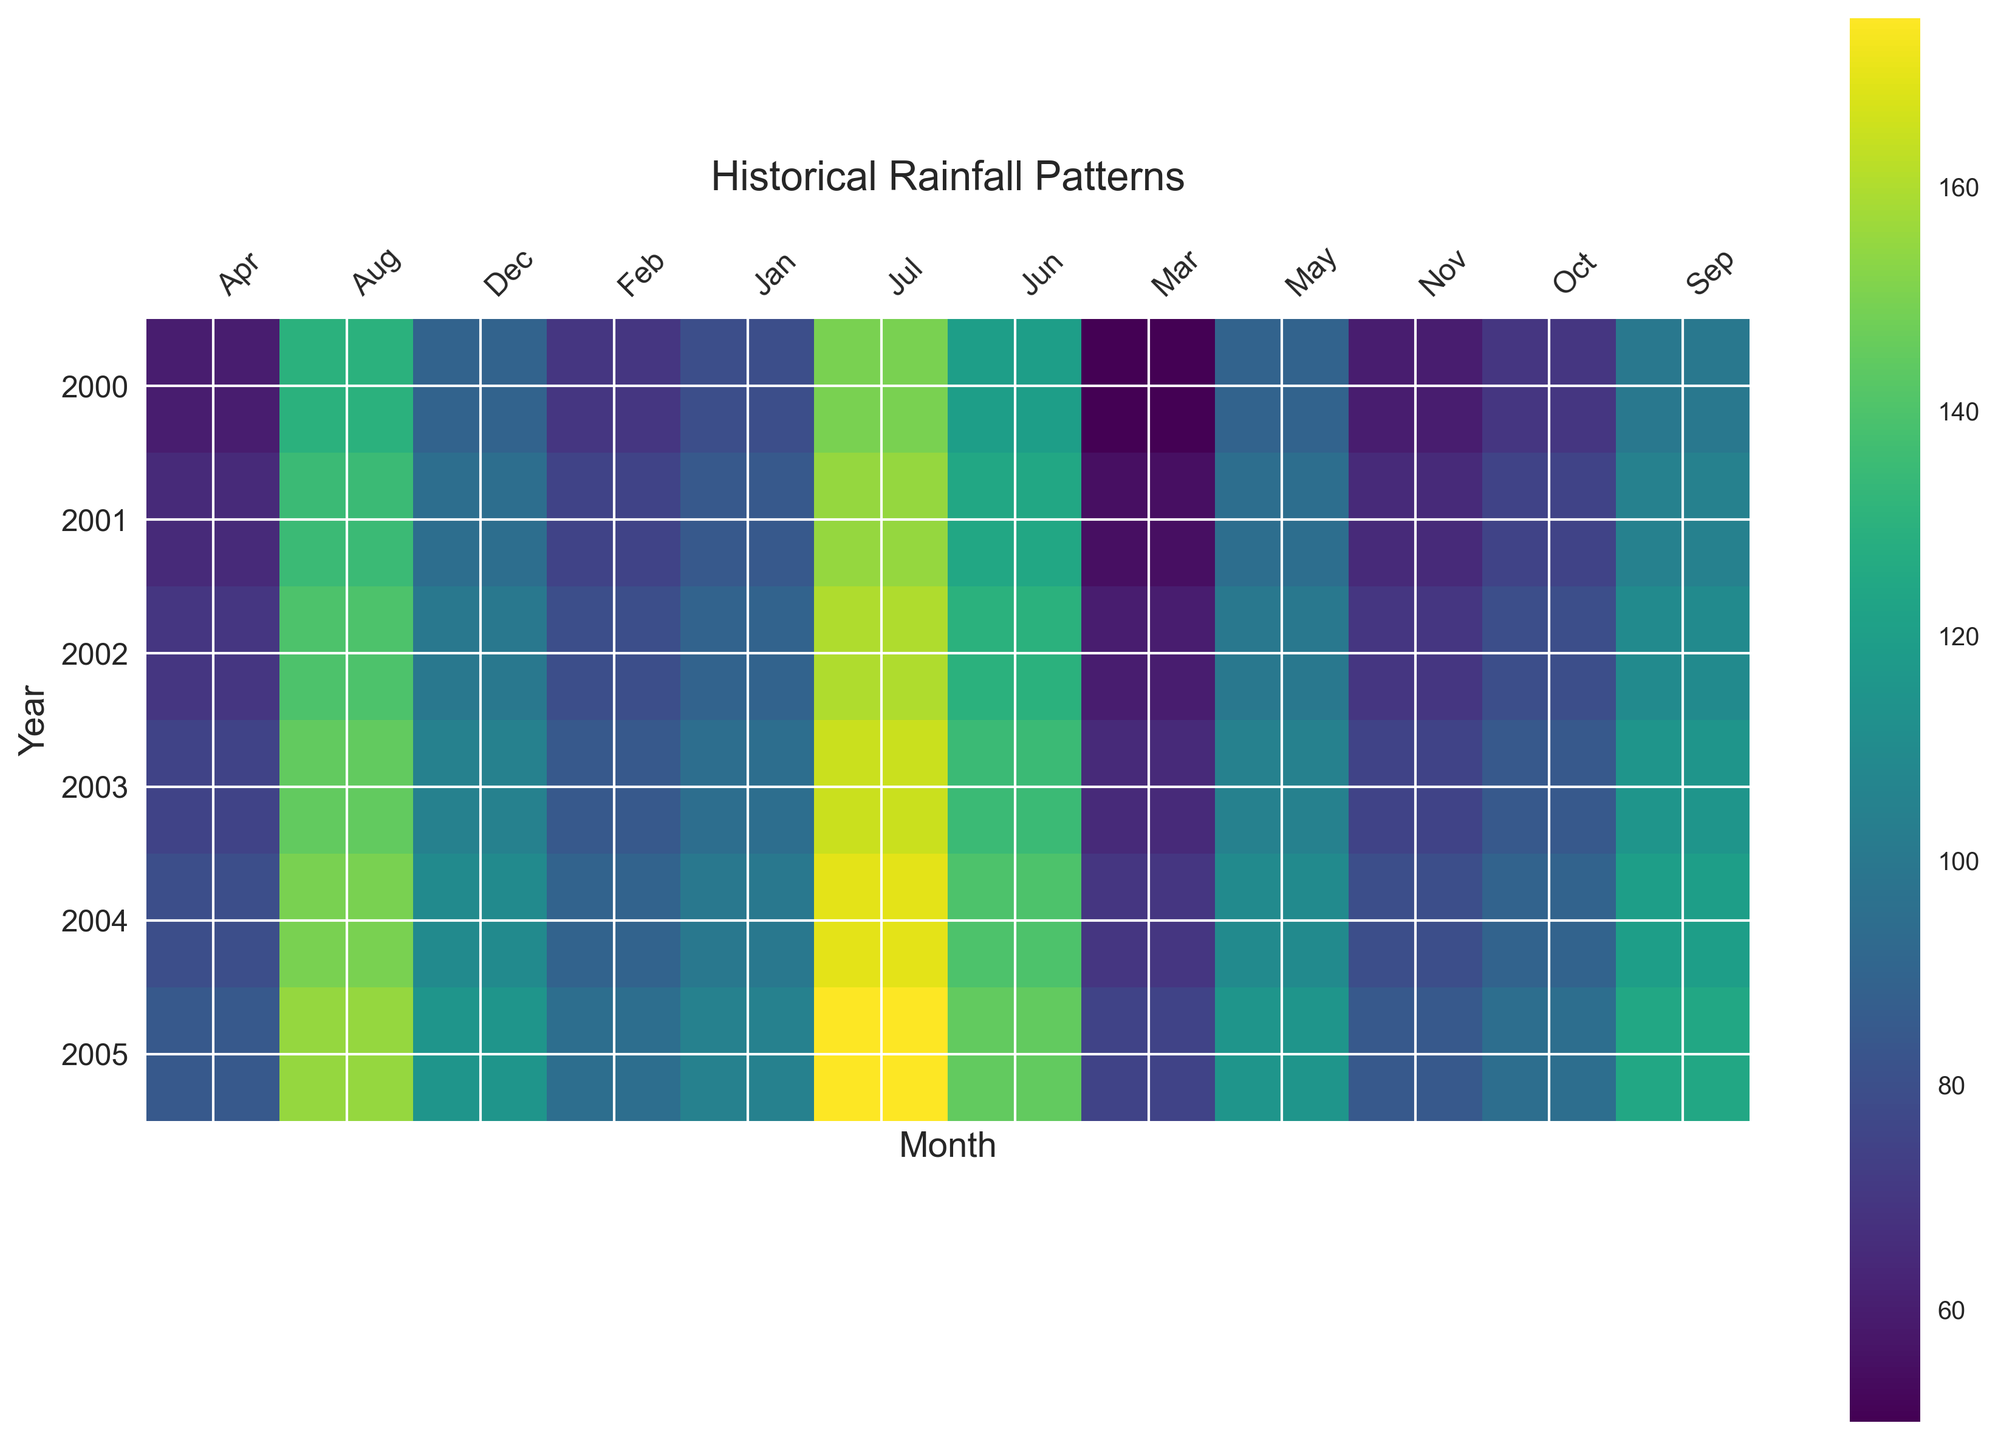What year experienced the highest average rainfall in July? Look for the month of July across all years, and identify the darkest hue which represents the highest rainfall. Reference the corresponding year.
Answer: 2005 Which year had the lowest average rainfall in March? Examine the March data across all years and seek the lightest hue indicating the lowest rainfall. The corresponding year is your answer.
Answer: 2000 Compare the average rainfall in August and September for the year 2004. Which month had more rainfall and by how much? Locate August and September for 2004 on the x-axis, compare the colors, and refer to the scale. The darker hue represents higher rainfall. Check the difference in shades.
Answer: August by 30 mm What is the overall trend in average rainfall from January to December for the year 2000? Trace the months of January to December for the year 2000 and observe the color progression. Identify if the colors gradually get darker, lighter, or vary.
Answer: Increasing, peaking mid-year, then decreasing Is there a noticeable seasonal pattern in average rainfall when comparing different years? Look across multiple years horizontally to see if certain months consistently show similar colors, indicating patterns by season. Summarize any consistent trends observed.
Answer: Yes, higher in summer months Which year showed the most consistent rainfall throughout the months? For each year, check if the colors are uniform across months. The year with the least variation in color is the most consistent.
Answer: 2000 In which month does the average rainfall peak most frequently across the years? Observe the darkest colors month by month across different years and identify which month most frequently has the darkest color, indicating a peak in rainfall.
Answer: July Are there any months where the average rainfall is consistently low across multiple years? Identify months where the colors are consistently lighter across the years, indicating low rainfall. Specify which months are most light across several years.
Answer: March How does the rainfall in June compare to January over the observed years? Scan through the colors representing June and January for all years and identify whether June typically has darker colors compared to January, indicating more rainfall.
Answer: June generally has more What is the variance in average rainfall between May and June in 2001? Identify the shades for May and June in 2001, determine the difference visually, and relate this to approximate rainfall values from the color bar.
Answer: Lower in May by approximately 30 mm 